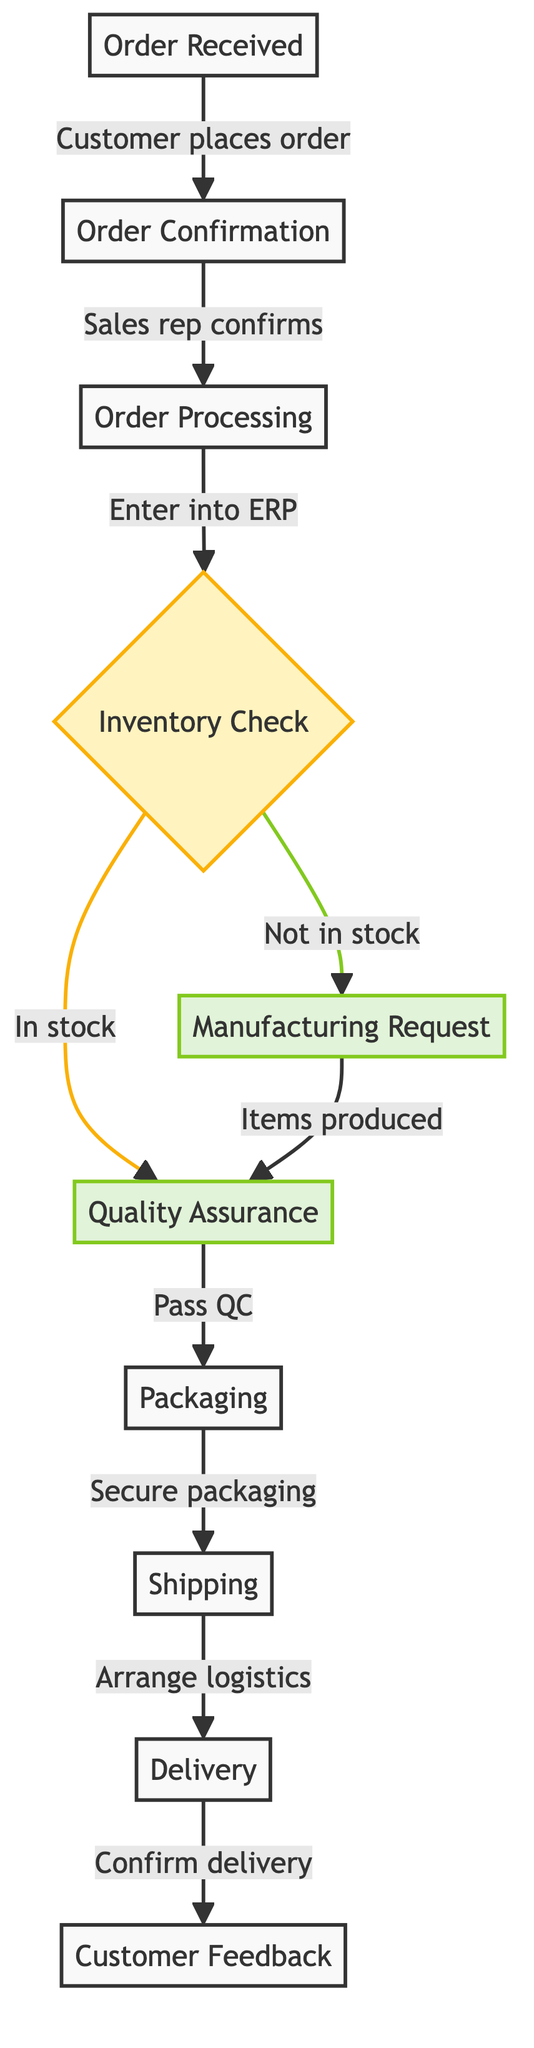What is the first step in the order fulfillment process? The first step listed in the flowchart is "Order Received," indicating that this is where the process begins.
Answer: Order Received How many main processes are there in the order fulfillment diagram? By examining the flowchart, there are a total of 10 distinct elements depicted, meaning there are 10 main processes in this order fulfillment diagram.
Answer: 10 What happens if the items are not in stock? The flowchart shows that if items are not in stock, a "Manufacturing Request" is generated to start the process of producing the required items.
Answer: Manufacturing Request Which step comes after quality assurance? According to the flowchart, after "Quality Assurance," the next step is "Packaging," where items are securely packaged for shipment.
Answer: Packaging What action is taken after shipping? The flowchart indicates that the next action after "Shipping" is "Delivery," where the products are delivered to the customer.
Answer: Delivery Which two steps are connected by a decision node? The decision node "Inventory Check" connects two steps: "Quality Assurance" (if items are in stock) and "Manufacturing Request" (if items are not in stock), indicating the inventory status determines the next step.
Answer: Inventory Check What is collected after the delivery is confirmed? Following the "Delivery" step, the process includes collecting "Customer Feedback," ensuring the customer's satisfaction with their order.
Answer: Customer Feedback When does the order processing begin? The order processing begins after the "Order Confirmation" step is completed, where the sales representative confirms the order details.
Answer: Order Processing What occurs at the "Quality Assurance" step? During "Quality Assurance," both manufactured and stocked items undergo quality control checks to ensure they meet required standards before proceeding further in the process.
Answer: Quality control checks 